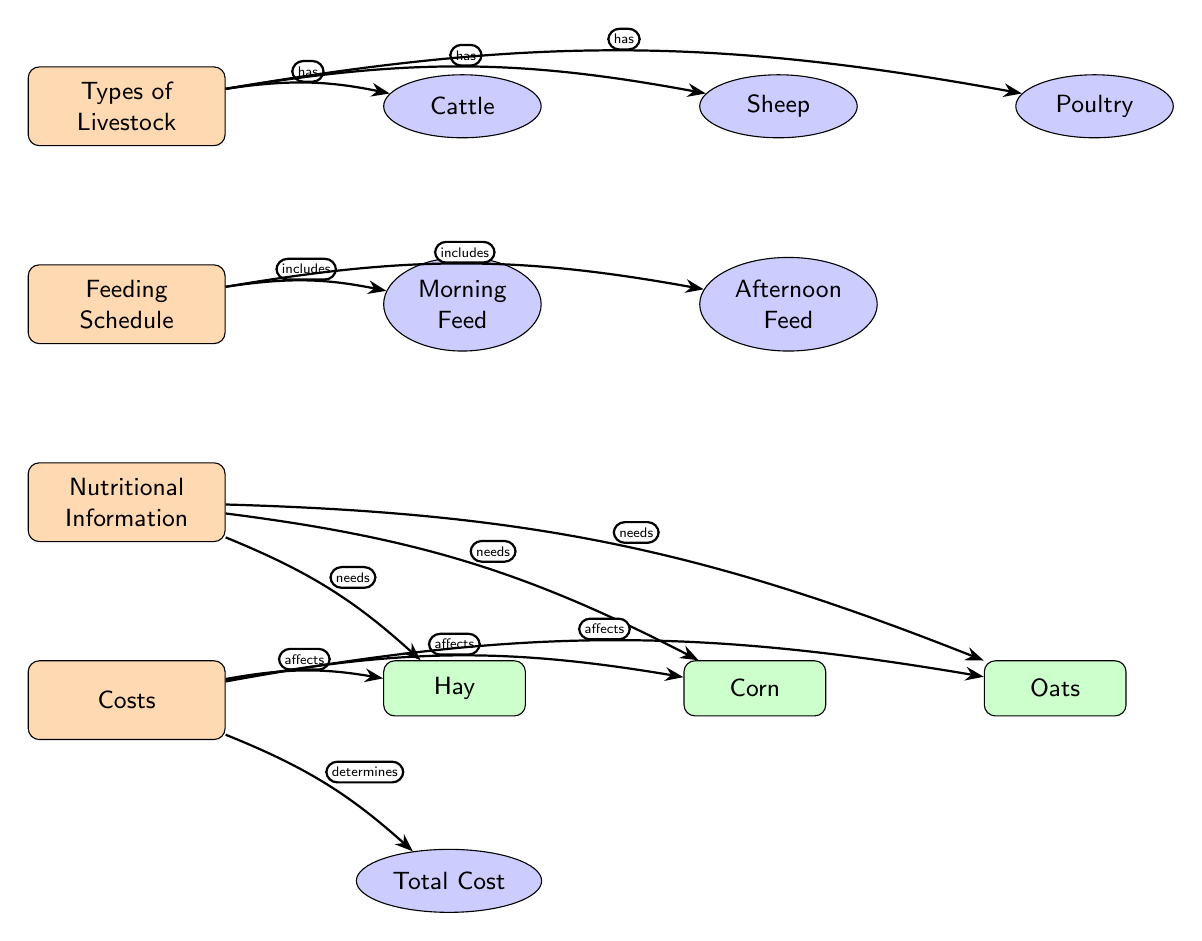What types of livestock are listed? The diagram shows three types of livestock: Cattle, Sheep, and Poultry. These are found on the right side of the main node "Types of Livestock."
Answer: Cattle, Sheep, Poultry How many feeding times are shown in the schedule? The feeding schedule includes two specific times: Morning Feed and Afternoon Feed, which are indicated as sub-nodes below the main node "Feeding Schedule."
Answer: 2 What nutritional items are mentioned? The nutritional information includes Hay, Corn, and Oats. These are leaf nodes connected to the main node "Nutritional Information."
Answer: Hay, Corn, Oats Which livestock type 'has' the 'Feeding Schedule'? The diagram indicates that the main node "Feeding Schedule" is connected to the node "Types of Livestock," with an arrow labeled "includes," meaning all livestock types follow the feeding schedule.
Answer: Livestock What does the 'Total Cost' affect? The "Total Cost" node is connected to the nutritional items Hay, Corn, and Oats, with arrows labeled "affects," indicating that costs are calculated based on these feed types.
Answer: Hay, Corn, Oats What connection type is used between 'Costs' and 'Nutritional Information'? The edge between "Costs" and "Nutritional Information" is labeled "affects," indicating a direct relationship where the costs impact nutritional needs.
Answer: Affects Which livestock type requires the most diverse feeding schedule? To determine this, we observe that all types of livestock (Cattle, Sheep, Poultry) share the same feeding schedule. Hence, they all require the same level of feeding diversity as indicated together in the “Feeding Schedule.”
Answer: All types How does nutritional need relate to costs? The diagram shows arrows from the nutritional items (Hay, Corn, Oats) to the "Costs" node labeled "affects," suggesting that the need for different feeds directly influences overall costs. Thus, nutritional needs contribute to the cost determination.
Answer: Affects Which node determines 'Total Cost'? The node connected to "Total Cost" is "Costs," specifically labeled with the arrow "determines," indicating that costs directly lead to the final total cost evaluation.
Answer: Costs 